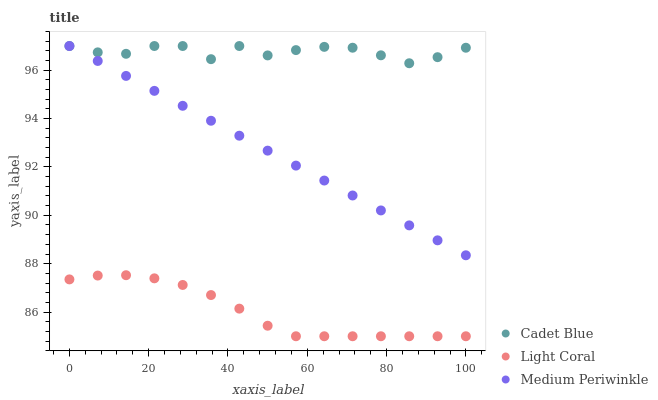Does Light Coral have the minimum area under the curve?
Answer yes or no. Yes. Does Cadet Blue have the maximum area under the curve?
Answer yes or no. Yes. Does Medium Periwinkle have the minimum area under the curve?
Answer yes or no. No. Does Medium Periwinkle have the maximum area under the curve?
Answer yes or no. No. Is Medium Periwinkle the smoothest?
Answer yes or no. Yes. Is Cadet Blue the roughest?
Answer yes or no. Yes. Is Cadet Blue the smoothest?
Answer yes or no. No. Is Medium Periwinkle the roughest?
Answer yes or no. No. Does Light Coral have the lowest value?
Answer yes or no. Yes. Does Medium Periwinkle have the lowest value?
Answer yes or no. No. Does Medium Periwinkle have the highest value?
Answer yes or no. Yes. Is Light Coral less than Medium Periwinkle?
Answer yes or no. Yes. Is Medium Periwinkle greater than Light Coral?
Answer yes or no. Yes. Does Medium Periwinkle intersect Cadet Blue?
Answer yes or no. Yes. Is Medium Periwinkle less than Cadet Blue?
Answer yes or no. No. Is Medium Periwinkle greater than Cadet Blue?
Answer yes or no. No. Does Light Coral intersect Medium Periwinkle?
Answer yes or no. No. 